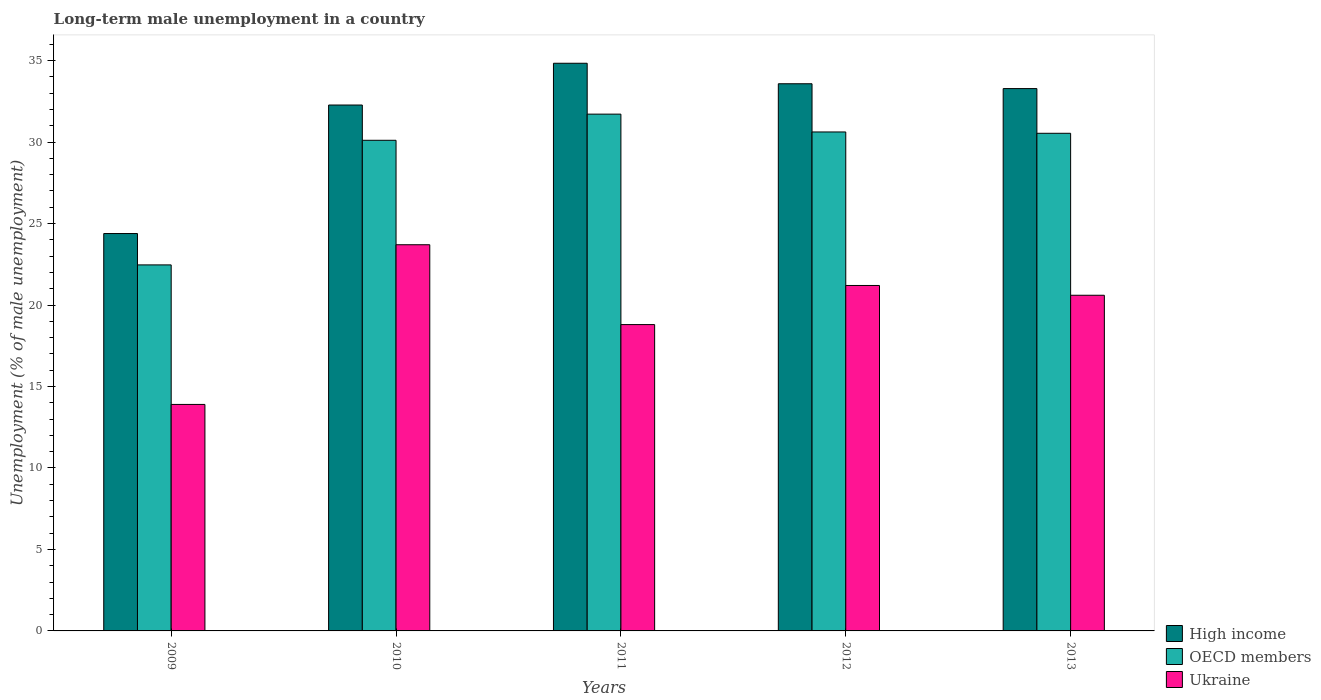How many groups of bars are there?
Provide a succinct answer. 5. Are the number of bars on each tick of the X-axis equal?
Ensure brevity in your answer.  Yes. How many bars are there on the 5th tick from the left?
Ensure brevity in your answer.  3. How many bars are there on the 1st tick from the right?
Keep it short and to the point. 3. What is the percentage of long-term unemployed male population in High income in 2009?
Ensure brevity in your answer.  24.39. Across all years, what is the maximum percentage of long-term unemployed male population in Ukraine?
Your response must be concise. 23.7. Across all years, what is the minimum percentage of long-term unemployed male population in Ukraine?
Provide a short and direct response. 13.9. In which year was the percentage of long-term unemployed male population in High income maximum?
Make the answer very short. 2011. What is the total percentage of long-term unemployed male population in OECD members in the graph?
Make the answer very short. 145.45. What is the difference between the percentage of long-term unemployed male population in OECD members in 2009 and that in 2010?
Ensure brevity in your answer.  -7.65. What is the difference between the percentage of long-term unemployed male population in OECD members in 2011 and the percentage of long-term unemployed male population in Ukraine in 2013?
Ensure brevity in your answer.  11.12. What is the average percentage of long-term unemployed male population in OECD members per year?
Keep it short and to the point. 29.09. In the year 2009, what is the difference between the percentage of long-term unemployed male population in High income and percentage of long-term unemployed male population in Ukraine?
Offer a very short reply. 10.49. What is the ratio of the percentage of long-term unemployed male population in High income in 2010 to that in 2011?
Your response must be concise. 0.93. Is the difference between the percentage of long-term unemployed male population in High income in 2009 and 2010 greater than the difference between the percentage of long-term unemployed male population in Ukraine in 2009 and 2010?
Your answer should be compact. Yes. What is the difference between the highest and the lowest percentage of long-term unemployed male population in High income?
Make the answer very short. 10.45. Is it the case that in every year, the sum of the percentage of long-term unemployed male population in OECD members and percentage of long-term unemployed male population in Ukraine is greater than the percentage of long-term unemployed male population in High income?
Provide a short and direct response. Yes. Are all the bars in the graph horizontal?
Offer a very short reply. No. How many years are there in the graph?
Your answer should be compact. 5. What is the difference between two consecutive major ticks on the Y-axis?
Provide a short and direct response. 5. Are the values on the major ticks of Y-axis written in scientific E-notation?
Offer a very short reply. No. Does the graph contain any zero values?
Your answer should be very brief. No. Does the graph contain grids?
Make the answer very short. No. Where does the legend appear in the graph?
Ensure brevity in your answer.  Bottom right. How are the legend labels stacked?
Make the answer very short. Vertical. What is the title of the graph?
Your answer should be very brief. Long-term male unemployment in a country. What is the label or title of the Y-axis?
Offer a terse response. Unemployment (% of male unemployment). What is the Unemployment (% of male unemployment) of High income in 2009?
Make the answer very short. 24.39. What is the Unemployment (% of male unemployment) in OECD members in 2009?
Give a very brief answer. 22.46. What is the Unemployment (% of male unemployment) in Ukraine in 2009?
Provide a succinct answer. 13.9. What is the Unemployment (% of male unemployment) in High income in 2010?
Provide a succinct answer. 32.28. What is the Unemployment (% of male unemployment) of OECD members in 2010?
Provide a short and direct response. 30.11. What is the Unemployment (% of male unemployment) of Ukraine in 2010?
Offer a terse response. 23.7. What is the Unemployment (% of male unemployment) of High income in 2011?
Ensure brevity in your answer.  34.84. What is the Unemployment (% of male unemployment) of OECD members in 2011?
Offer a very short reply. 31.72. What is the Unemployment (% of male unemployment) in Ukraine in 2011?
Offer a very short reply. 18.8. What is the Unemployment (% of male unemployment) of High income in 2012?
Provide a succinct answer. 33.58. What is the Unemployment (% of male unemployment) in OECD members in 2012?
Keep it short and to the point. 30.62. What is the Unemployment (% of male unemployment) in Ukraine in 2012?
Offer a very short reply. 21.2. What is the Unemployment (% of male unemployment) in High income in 2013?
Ensure brevity in your answer.  33.28. What is the Unemployment (% of male unemployment) of OECD members in 2013?
Give a very brief answer. 30.54. What is the Unemployment (% of male unemployment) of Ukraine in 2013?
Make the answer very short. 20.6. Across all years, what is the maximum Unemployment (% of male unemployment) in High income?
Keep it short and to the point. 34.84. Across all years, what is the maximum Unemployment (% of male unemployment) of OECD members?
Your answer should be very brief. 31.72. Across all years, what is the maximum Unemployment (% of male unemployment) of Ukraine?
Offer a terse response. 23.7. Across all years, what is the minimum Unemployment (% of male unemployment) in High income?
Provide a succinct answer. 24.39. Across all years, what is the minimum Unemployment (% of male unemployment) in OECD members?
Offer a terse response. 22.46. Across all years, what is the minimum Unemployment (% of male unemployment) in Ukraine?
Make the answer very short. 13.9. What is the total Unemployment (% of male unemployment) of High income in the graph?
Offer a very short reply. 158.37. What is the total Unemployment (% of male unemployment) in OECD members in the graph?
Give a very brief answer. 145.45. What is the total Unemployment (% of male unemployment) in Ukraine in the graph?
Provide a short and direct response. 98.2. What is the difference between the Unemployment (% of male unemployment) of High income in 2009 and that in 2010?
Your answer should be compact. -7.89. What is the difference between the Unemployment (% of male unemployment) in OECD members in 2009 and that in 2010?
Give a very brief answer. -7.65. What is the difference between the Unemployment (% of male unemployment) of High income in 2009 and that in 2011?
Offer a terse response. -10.45. What is the difference between the Unemployment (% of male unemployment) in OECD members in 2009 and that in 2011?
Your answer should be very brief. -9.25. What is the difference between the Unemployment (% of male unemployment) in Ukraine in 2009 and that in 2011?
Ensure brevity in your answer.  -4.9. What is the difference between the Unemployment (% of male unemployment) in High income in 2009 and that in 2012?
Offer a terse response. -9.19. What is the difference between the Unemployment (% of male unemployment) of OECD members in 2009 and that in 2012?
Your answer should be compact. -8.16. What is the difference between the Unemployment (% of male unemployment) in High income in 2009 and that in 2013?
Provide a short and direct response. -8.9. What is the difference between the Unemployment (% of male unemployment) of OECD members in 2009 and that in 2013?
Offer a very short reply. -8.08. What is the difference between the Unemployment (% of male unemployment) of High income in 2010 and that in 2011?
Ensure brevity in your answer.  -2.56. What is the difference between the Unemployment (% of male unemployment) in OECD members in 2010 and that in 2011?
Ensure brevity in your answer.  -1.61. What is the difference between the Unemployment (% of male unemployment) of High income in 2010 and that in 2012?
Your answer should be compact. -1.3. What is the difference between the Unemployment (% of male unemployment) in OECD members in 2010 and that in 2012?
Provide a short and direct response. -0.51. What is the difference between the Unemployment (% of male unemployment) of Ukraine in 2010 and that in 2012?
Offer a terse response. 2.5. What is the difference between the Unemployment (% of male unemployment) in High income in 2010 and that in 2013?
Give a very brief answer. -1.01. What is the difference between the Unemployment (% of male unemployment) in OECD members in 2010 and that in 2013?
Your response must be concise. -0.43. What is the difference between the Unemployment (% of male unemployment) of Ukraine in 2010 and that in 2013?
Offer a very short reply. 3.1. What is the difference between the Unemployment (% of male unemployment) of High income in 2011 and that in 2012?
Provide a succinct answer. 1.26. What is the difference between the Unemployment (% of male unemployment) in OECD members in 2011 and that in 2012?
Offer a very short reply. 1.09. What is the difference between the Unemployment (% of male unemployment) of High income in 2011 and that in 2013?
Ensure brevity in your answer.  1.55. What is the difference between the Unemployment (% of male unemployment) of OECD members in 2011 and that in 2013?
Provide a succinct answer. 1.18. What is the difference between the Unemployment (% of male unemployment) in Ukraine in 2011 and that in 2013?
Give a very brief answer. -1.8. What is the difference between the Unemployment (% of male unemployment) in High income in 2012 and that in 2013?
Offer a terse response. 0.3. What is the difference between the Unemployment (% of male unemployment) in OECD members in 2012 and that in 2013?
Keep it short and to the point. 0.08. What is the difference between the Unemployment (% of male unemployment) in Ukraine in 2012 and that in 2013?
Ensure brevity in your answer.  0.6. What is the difference between the Unemployment (% of male unemployment) in High income in 2009 and the Unemployment (% of male unemployment) in OECD members in 2010?
Provide a succinct answer. -5.72. What is the difference between the Unemployment (% of male unemployment) of High income in 2009 and the Unemployment (% of male unemployment) of Ukraine in 2010?
Provide a succinct answer. 0.69. What is the difference between the Unemployment (% of male unemployment) in OECD members in 2009 and the Unemployment (% of male unemployment) in Ukraine in 2010?
Ensure brevity in your answer.  -1.24. What is the difference between the Unemployment (% of male unemployment) of High income in 2009 and the Unemployment (% of male unemployment) of OECD members in 2011?
Give a very brief answer. -7.33. What is the difference between the Unemployment (% of male unemployment) in High income in 2009 and the Unemployment (% of male unemployment) in Ukraine in 2011?
Provide a succinct answer. 5.59. What is the difference between the Unemployment (% of male unemployment) of OECD members in 2009 and the Unemployment (% of male unemployment) of Ukraine in 2011?
Make the answer very short. 3.66. What is the difference between the Unemployment (% of male unemployment) of High income in 2009 and the Unemployment (% of male unemployment) of OECD members in 2012?
Your answer should be very brief. -6.23. What is the difference between the Unemployment (% of male unemployment) of High income in 2009 and the Unemployment (% of male unemployment) of Ukraine in 2012?
Your answer should be compact. 3.19. What is the difference between the Unemployment (% of male unemployment) in OECD members in 2009 and the Unemployment (% of male unemployment) in Ukraine in 2012?
Give a very brief answer. 1.26. What is the difference between the Unemployment (% of male unemployment) of High income in 2009 and the Unemployment (% of male unemployment) of OECD members in 2013?
Make the answer very short. -6.15. What is the difference between the Unemployment (% of male unemployment) of High income in 2009 and the Unemployment (% of male unemployment) of Ukraine in 2013?
Make the answer very short. 3.79. What is the difference between the Unemployment (% of male unemployment) of OECD members in 2009 and the Unemployment (% of male unemployment) of Ukraine in 2013?
Give a very brief answer. 1.86. What is the difference between the Unemployment (% of male unemployment) in High income in 2010 and the Unemployment (% of male unemployment) in OECD members in 2011?
Make the answer very short. 0.56. What is the difference between the Unemployment (% of male unemployment) in High income in 2010 and the Unemployment (% of male unemployment) in Ukraine in 2011?
Your response must be concise. 13.48. What is the difference between the Unemployment (% of male unemployment) of OECD members in 2010 and the Unemployment (% of male unemployment) of Ukraine in 2011?
Give a very brief answer. 11.31. What is the difference between the Unemployment (% of male unemployment) in High income in 2010 and the Unemployment (% of male unemployment) in OECD members in 2012?
Keep it short and to the point. 1.65. What is the difference between the Unemployment (% of male unemployment) of High income in 2010 and the Unemployment (% of male unemployment) of Ukraine in 2012?
Give a very brief answer. 11.08. What is the difference between the Unemployment (% of male unemployment) of OECD members in 2010 and the Unemployment (% of male unemployment) of Ukraine in 2012?
Give a very brief answer. 8.91. What is the difference between the Unemployment (% of male unemployment) of High income in 2010 and the Unemployment (% of male unemployment) of OECD members in 2013?
Offer a very short reply. 1.73. What is the difference between the Unemployment (% of male unemployment) in High income in 2010 and the Unemployment (% of male unemployment) in Ukraine in 2013?
Your response must be concise. 11.68. What is the difference between the Unemployment (% of male unemployment) in OECD members in 2010 and the Unemployment (% of male unemployment) in Ukraine in 2013?
Provide a short and direct response. 9.51. What is the difference between the Unemployment (% of male unemployment) of High income in 2011 and the Unemployment (% of male unemployment) of OECD members in 2012?
Your answer should be compact. 4.22. What is the difference between the Unemployment (% of male unemployment) of High income in 2011 and the Unemployment (% of male unemployment) of Ukraine in 2012?
Provide a succinct answer. 13.64. What is the difference between the Unemployment (% of male unemployment) in OECD members in 2011 and the Unemployment (% of male unemployment) in Ukraine in 2012?
Keep it short and to the point. 10.52. What is the difference between the Unemployment (% of male unemployment) of High income in 2011 and the Unemployment (% of male unemployment) of OECD members in 2013?
Provide a succinct answer. 4.3. What is the difference between the Unemployment (% of male unemployment) in High income in 2011 and the Unemployment (% of male unemployment) in Ukraine in 2013?
Provide a succinct answer. 14.24. What is the difference between the Unemployment (% of male unemployment) of OECD members in 2011 and the Unemployment (% of male unemployment) of Ukraine in 2013?
Your answer should be very brief. 11.12. What is the difference between the Unemployment (% of male unemployment) in High income in 2012 and the Unemployment (% of male unemployment) in OECD members in 2013?
Ensure brevity in your answer.  3.04. What is the difference between the Unemployment (% of male unemployment) in High income in 2012 and the Unemployment (% of male unemployment) in Ukraine in 2013?
Ensure brevity in your answer.  12.98. What is the difference between the Unemployment (% of male unemployment) in OECD members in 2012 and the Unemployment (% of male unemployment) in Ukraine in 2013?
Offer a terse response. 10.02. What is the average Unemployment (% of male unemployment) in High income per year?
Offer a terse response. 31.67. What is the average Unemployment (% of male unemployment) in OECD members per year?
Provide a short and direct response. 29.09. What is the average Unemployment (% of male unemployment) of Ukraine per year?
Give a very brief answer. 19.64. In the year 2009, what is the difference between the Unemployment (% of male unemployment) in High income and Unemployment (% of male unemployment) in OECD members?
Provide a short and direct response. 1.93. In the year 2009, what is the difference between the Unemployment (% of male unemployment) of High income and Unemployment (% of male unemployment) of Ukraine?
Your answer should be compact. 10.49. In the year 2009, what is the difference between the Unemployment (% of male unemployment) of OECD members and Unemployment (% of male unemployment) of Ukraine?
Keep it short and to the point. 8.56. In the year 2010, what is the difference between the Unemployment (% of male unemployment) in High income and Unemployment (% of male unemployment) in OECD members?
Your answer should be compact. 2.16. In the year 2010, what is the difference between the Unemployment (% of male unemployment) in High income and Unemployment (% of male unemployment) in Ukraine?
Give a very brief answer. 8.58. In the year 2010, what is the difference between the Unemployment (% of male unemployment) of OECD members and Unemployment (% of male unemployment) of Ukraine?
Offer a very short reply. 6.41. In the year 2011, what is the difference between the Unemployment (% of male unemployment) of High income and Unemployment (% of male unemployment) of OECD members?
Your answer should be compact. 3.12. In the year 2011, what is the difference between the Unemployment (% of male unemployment) of High income and Unemployment (% of male unemployment) of Ukraine?
Your answer should be compact. 16.04. In the year 2011, what is the difference between the Unemployment (% of male unemployment) in OECD members and Unemployment (% of male unemployment) in Ukraine?
Your answer should be very brief. 12.92. In the year 2012, what is the difference between the Unemployment (% of male unemployment) of High income and Unemployment (% of male unemployment) of OECD members?
Ensure brevity in your answer.  2.96. In the year 2012, what is the difference between the Unemployment (% of male unemployment) in High income and Unemployment (% of male unemployment) in Ukraine?
Make the answer very short. 12.38. In the year 2012, what is the difference between the Unemployment (% of male unemployment) in OECD members and Unemployment (% of male unemployment) in Ukraine?
Your answer should be very brief. 9.42. In the year 2013, what is the difference between the Unemployment (% of male unemployment) of High income and Unemployment (% of male unemployment) of OECD members?
Give a very brief answer. 2.74. In the year 2013, what is the difference between the Unemployment (% of male unemployment) of High income and Unemployment (% of male unemployment) of Ukraine?
Offer a very short reply. 12.68. In the year 2013, what is the difference between the Unemployment (% of male unemployment) in OECD members and Unemployment (% of male unemployment) in Ukraine?
Your answer should be compact. 9.94. What is the ratio of the Unemployment (% of male unemployment) in High income in 2009 to that in 2010?
Your response must be concise. 0.76. What is the ratio of the Unemployment (% of male unemployment) in OECD members in 2009 to that in 2010?
Your answer should be very brief. 0.75. What is the ratio of the Unemployment (% of male unemployment) in Ukraine in 2009 to that in 2010?
Ensure brevity in your answer.  0.59. What is the ratio of the Unemployment (% of male unemployment) in OECD members in 2009 to that in 2011?
Provide a short and direct response. 0.71. What is the ratio of the Unemployment (% of male unemployment) in Ukraine in 2009 to that in 2011?
Your response must be concise. 0.74. What is the ratio of the Unemployment (% of male unemployment) in High income in 2009 to that in 2012?
Provide a succinct answer. 0.73. What is the ratio of the Unemployment (% of male unemployment) of OECD members in 2009 to that in 2012?
Give a very brief answer. 0.73. What is the ratio of the Unemployment (% of male unemployment) of Ukraine in 2009 to that in 2012?
Your response must be concise. 0.66. What is the ratio of the Unemployment (% of male unemployment) in High income in 2009 to that in 2013?
Make the answer very short. 0.73. What is the ratio of the Unemployment (% of male unemployment) in OECD members in 2009 to that in 2013?
Your answer should be compact. 0.74. What is the ratio of the Unemployment (% of male unemployment) in Ukraine in 2009 to that in 2013?
Keep it short and to the point. 0.67. What is the ratio of the Unemployment (% of male unemployment) of High income in 2010 to that in 2011?
Give a very brief answer. 0.93. What is the ratio of the Unemployment (% of male unemployment) in OECD members in 2010 to that in 2011?
Give a very brief answer. 0.95. What is the ratio of the Unemployment (% of male unemployment) in Ukraine in 2010 to that in 2011?
Your answer should be very brief. 1.26. What is the ratio of the Unemployment (% of male unemployment) in High income in 2010 to that in 2012?
Your response must be concise. 0.96. What is the ratio of the Unemployment (% of male unemployment) in OECD members in 2010 to that in 2012?
Your answer should be very brief. 0.98. What is the ratio of the Unemployment (% of male unemployment) of Ukraine in 2010 to that in 2012?
Offer a very short reply. 1.12. What is the ratio of the Unemployment (% of male unemployment) of High income in 2010 to that in 2013?
Your response must be concise. 0.97. What is the ratio of the Unemployment (% of male unemployment) in OECD members in 2010 to that in 2013?
Your response must be concise. 0.99. What is the ratio of the Unemployment (% of male unemployment) in Ukraine in 2010 to that in 2013?
Provide a short and direct response. 1.15. What is the ratio of the Unemployment (% of male unemployment) of High income in 2011 to that in 2012?
Provide a succinct answer. 1.04. What is the ratio of the Unemployment (% of male unemployment) in OECD members in 2011 to that in 2012?
Provide a succinct answer. 1.04. What is the ratio of the Unemployment (% of male unemployment) of Ukraine in 2011 to that in 2012?
Your answer should be very brief. 0.89. What is the ratio of the Unemployment (% of male unemployment) in High income in 2011 to that in 2013?
Offer a very short reply. 1.05. What is the ratio of the Unemployment (% of male unemployment) of Ukraine in 2011 to that in 2013?
Your response must be concise. 0.91. What is the ratio of the Unemployment (% of male unemployment) in High income in 2012 to that in 2013?
Provide a succinct answer. 1.01. What is the ratio of the Unemployment (% of male unemployment) of Ukraine in 2012 to that in 2013?
Provide a succinct answer. 1.03. What is the difference between the highest and the second highest Unemployment (% of male unemployment) of High income?
Your answer should be compact. 1.26. What is the difference between the highest and the second highest Unemployment (% of male unemployment) of OECD members?
Your answer should be compact. 1.09. What is the difference between the highest and the second highest Unemployment (% of male unemployment) of Ukraine?
Give a very brief answer. 2.5. What is the difference between the highest and the lowest Unemployment (% of male unemployment) in High income?
Provide a short and direct response. 10.45. What is the difference between the highest and the lowest Unemployment (% of male unemployment) in OECD members?
Your response must be concise. 9.25. What is the difference between the highest and the lowest Unemployment (% of male unemployment) in Ukraine?
Keep it short and to the point. 9.8. 